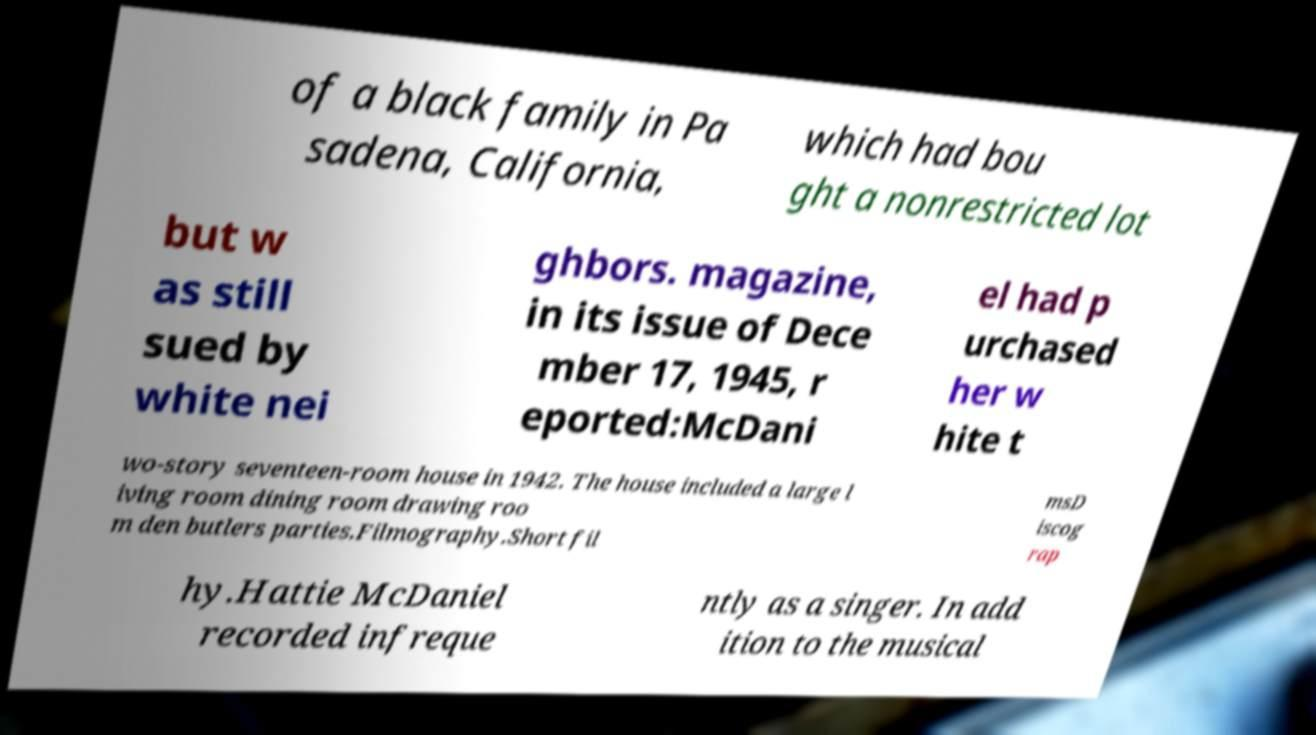Please identify and transcribe the text found in this image. of a black family in Pa sadena, California, which had bou ght a nonrestricted lot but w as still sued by white nei ghbors. magazine, in its issue of Dece mber 17, 1945, r eported:McDani el had p urchased her w hite t wo-story seventeen-room house in 1942. The house included a large l iving room dining room drawing roo m den butlers parties.Filmography.Short fil msD iscog rap hy.Hattie McDaniel recorded infreque ntly as a singer. In add ition to the musical 